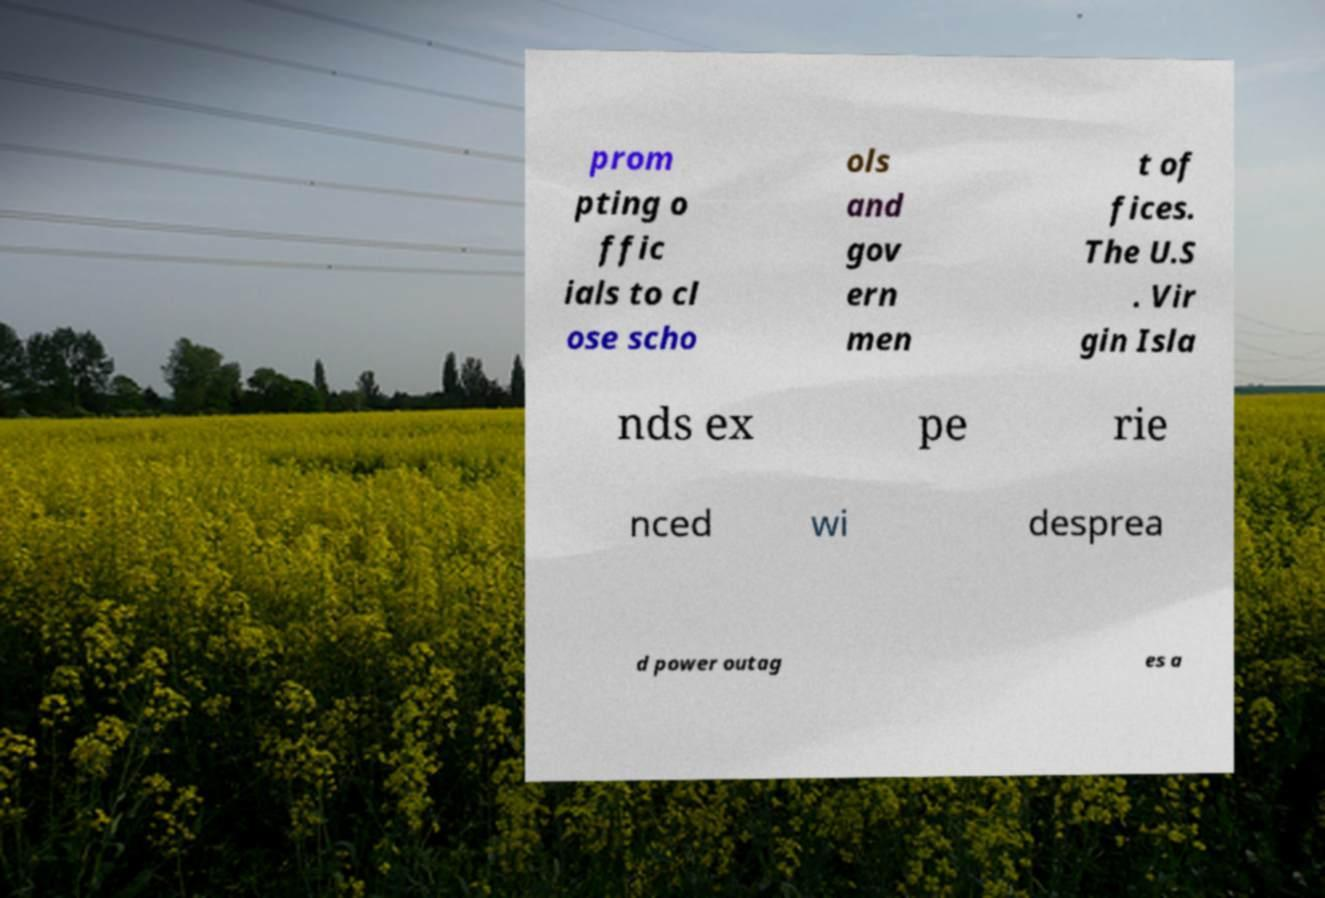I need the written content from this picture converted into text. Can you do that? prom pting o ffic ials to cl ose scho ols and gov ern men t of fices. The U.S . Vir gin Isla nds ex pe rie nced wi desprea d power outag es a 